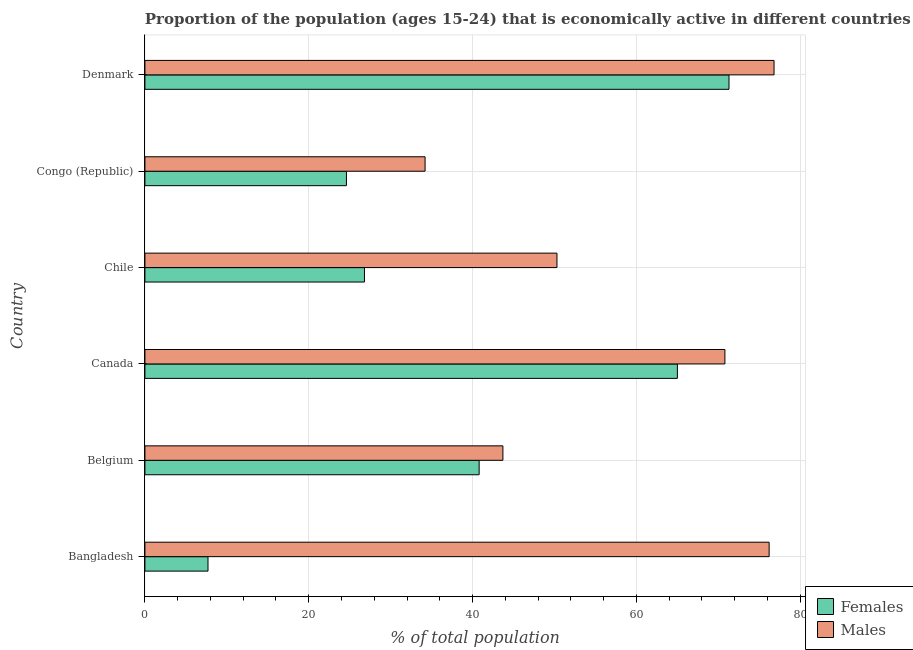How many different coloured bars are there?
Offer a very short reply. 2. How many groups of bars are there?
Ensure brevity in your answer.  6. Are the number of bars per tick equal to the number of legend labels?
Make the answer very short. Yes. How many bars are there on the 5th tick from the top?
Give a very brief answer. 2. How many bars are there on the 2nd tick from the bottom?
Provide a succinct answer. 2. What is the label of the 3rd group of bars from the top?
Make the answer very short. Chile. What is the percentage of economically active female population in Denmark?
Offer a terse response. 71.3. Across all countries, what is the maximum percentage of economically active female population?
Ensure brevity in your answer.  71.3. Across all countries, what is the minimum percentage of economically active male population?
Keep it short and to the point. 34.2. In which country was the percentage of economically active male population maximum?
Keep it short and to the point. Denmark. In which country was the percentage of economically active female population minimum?
Ensure brevity in your answer.  Bangladesh. What is the total percentage of economically active female population in the graph?
Ensure brevity in your answer.  236.2. What is the difference between the percentage of economically active male population in Chile and that in Denmark?
Offer a very short reply. -26.5. What is the difference between the percentage of economically active female population in Canada and the percentage of economically active male population in Belgium?
Provide a succinct answer. 21.3. What is the average percentage of economically active male population per country?
Offer a terse response. 58.67. What is the difference between the percentage of economically active male population and percentage of economically active female population in Canada?
Make the answer very short. 5.8. In how many countries, is the percentage of economically active female population greater than 36 %?
Your response must be concise. 3. What is the ratio of the percentage of economically active male population in Belgium to that in Canada?
Provide a short and direct response. 0.62. Is the difference between the percentage of economically active male population in Canada and Chile greater than the difference between the percentage of economically active female population in Canada and Chile?
Provide a short and direct response. No. What is the difference between the highest and the lowest percentage of economically active female population?
Your answer should be compact. 63.6. Is the sum of the percentage of economically active male population in Chile and Denmark greater than the maximum percentage of economically active female population across all countries?
Give a very brief answer. Yes. What does the 1st bar from the top in Bangladesh represents?
Make the answer very short. Males. What does the 1st bar from the bottom in Canada represents?
Provide a succinct answer. Females. Are all the bars in the graph horizontal?
Provide a short and direct response. Yes. Are the values on the major ticks of X-axis written in scientific E-notation?
Offer a very short reply. No. Does the graph contain grids?
Provide a short and direct response. Yes. What is the title of the graph?
Your answer should be compact. Proportion of the population (ages 15-24) that is economically active in different countries. Does "Private consumption" appear as one of the legend labels in the graph?
Offer a terse response. No. What is the label or title of the X-axis?
Ensure brevity in your answer.  % of total population. What is the % of total population of Females in Bangladesh?
Provide a short and direct response. 7.7. What is the % of total population in Males in Bangladesh?
Your answer should be compact. 76.2. What is the % of total population in Females in Belgium?
Your answer should be very brief. 40.8. What is the % of total population in Males in Belgium?
Your answer should be very brief. 43.7. What is the % of total population of Males in Canada?
Your response must be concise. 70.8. What is the % of total population of Females in Chile?
Keep it short and to the point. 26.8. What is the % of total population of Males in Chile?
Offer a very short reply. 50.3. What is the % of total population of Females in Congo (Republic)?
Your answer should be compact. 24.6. What is the % of total population of Males in Congo (Republic)?
Your response must be concise. 34.2. What is the % of total population of Females in Denmark?
Your answer should be very brief. 71.3. What is the % of total population of Males in Denmark?
Your answer should be compact. 76.8. Across all countries, what is the maximum % of total population of Females?
Give a very brief answer. 71.3. Across all countries, what is the maximum % of total population in Males?
Keep it short and to the point. 76.8. Across all countries, what is the minimum % of total population in Females?
Make the answer very short. 7.7. Across all countries, what is the minimum % of total population of Males?
Ensure brevity in your answer.  34.2. What is the total % of total population in Females in the graph?
Provide a short and direct response. 236.2. What is the total % of total population of Males in the graph?
Ensure brevity in your answer.  352. What is the difference between the % of total population of Females in Bangladesh and that in Belgium?
Ensure brevity in your answer.  -33.1. What is the difference between the % of total population in Males in Bangladesh and that in Belgium?
Provide a short and direct response. 32.5. What is the difference between the % of total population in Females in Bangladesh and that in Canada?
Provide a short and direct response. -57.3. What is the difference between the % of total population of Males in Bangladesh and that in Canada?
Offer a terse response. 5.4. What is the difference between the % of total population of Females in Bangladesh and that in Chile?
Provide a succinct answer. -19.1. What is the difference between the % of total population in Males in Bangladesh and that in Chile?
Your answer should be very brief. 25.9. What is the difference between the % of total population in Females in Bangladesh and that in Congo (Republic)?
Your answer should be compact. -16.9. What is the difference between the % of total population of Males in Bangladesh and that in Congo (Republic)?
Ensure brevity in your answer.  42. What is the difference between the % of total population of Females in Bangladesh and that in Denmark?
Offer a very short reply. -63.6. What is the difference between the % of total population in Females in Belgium and that in Canada?
Ensure brevity in your answer.  -24.2. What is the difference between the % of total population in Males in Belgium and that in Canada?
Keep it short and to the point. -27.1. What is the difference between the % of total population of Females in Belgium and that in Chile?
Give a very brief answer. 14. What is the difference between the % of total population in Females in Belgium and that in Congo (Republic)?
Keep it short and to the point. 16.2. What is the difference between the % of total population of Males in Belgium and that in Congo (Republic)?
Your answer should be very brief. 9.5. What is the difference between the % of total population of Females in Belgium and that in Denmark?
Offer a very short reply. -30.5. What is the difference between the % of total population of Males in Belgium and that in Denmark?
Provide a succinct answer. -33.1. What is the difference between the % of total population in Females in Canada and that in Chile?
Keep it short and to the point. 38.2. What is the difference between the % of total population of Females in Canada and that in Congo (Republic)?
Keep it short and to the point. 40.4. What is the difference between the % of total population of Males in Canada and that in Congo (Republic)?
Your answer should be very brief. 36.6. What is the difference between the % of total population in Males in Canada and that in Denmark?
Your answer should be compact. -6. What is the difference between the % of total population of Females in Chile and that in Congo (Republic)?
Offer a terse response. 2.2. What is the difference between the % of total population of Females in Chile and that in Denmark?
Make the answer very short. -44.5. What is the difference between the % of total population of Males in Chile and that in Denmark?
Your answer should be very brief. -26.5. What is the difference between the % of total population in Females in Congo (Republic) and that in Denmark?
Your response must be concise. -46.7. What is the difference between the % of total population in Males in Congo (Republic) and that in Denmark?
Your answer should be compact. -42.6. What is the difference between the % of total population in Females in Bangladesh and the % of total population in Males in Belgium?
Give a very brief answer. -36. What is the difference between the % of total population of Females in Bangladesh and the % of total population of Males in Canada?
Make the answer very short. -63.1. What is the difference between the % of total population in Females in Bangladesh and the % of total population in Males in Chile?
Provide a short and direct response. -42.6. What is the difference between the % of total population in Females in Bangladesh and the % of total population in Males in Congo (Republic)?
Ensure brevity in your answer.  -26.5. What is the difference between the % of total population of Females in Bangladesh and the % of total population of Males in Denmark?
Provide a short and direct response. -69.1. What is the difference between the % of total population of Females in Belgium and the % of total population of Males in Canada?
Provide a short and direct response. -30. What is the difference between the % of total population in Females in Belgium and the % of total population in Males in Denmark?
Provide a succinct answer. -36. What is the difference between the % of total population of Females in Canada and the % of total population of Males in Chile?
Keep it short and to the point. 14.7. What is the difference between the % of total population in Females in Canada and the % of total population in Males in Congo (Republic)?
Provide a short and direct response. 30.8. What is the difference between the % of total population in Females in Canada and the % of total population in Males in Denmark?
Provide a short and direct response. -11.8. What is the difference between the % of total population of Females in Chile and the % of total population of Males in Congo (Republic)?
Your response must be concise. -7.4. What is the difference between the % of total population of Females in Congo (Republic) and the % of total population of Males in Denmark?
Make the answer very short. -52.2. What is the average % of total population of Females per country?
Give a very brief answer. 39.37. What is the average % of total population of Males per country?
Offer a very short reply. 58.67. What is the difference between the % of total population of Females and % of total population of Males in Bangladesh?
Your answer should be compact. -68.5. What is the difference between the % of total population in Females and % of total population in Males in Canada?
Your response must be concise. -5.8. What is the difference between the % of total population of Females and % of total population of Males in Chile?
Provide a short and direct response. -23.5. What is the difference between the % of total population of Females and % of total population of Males in Congo (Republic)?
Make the answer very short. -9.6. What is the ratio of the % of total population of Females in Bangladesh to that in Belgium?
Make the answer very short. 0.19. What is the ratio of the % of total population of Males in Bangladesh to that in Belgium?
Give a very brief answer. 1.74. What is the ratio of the % of total population in Females in Bangladesh to that in Canada?
Your response must be concise. 0.12. What is the ratio of the % of total population in Males in Bangladesh to that in Canada?
Your answer should be compact. 1.08. What is the ratio of the % of total population in Females in Bangladesh to that in Chile?
Offer a very short reply. 0.29. What is the ratio of the % of total population of Males in Bangladesh to that in Chile?
Offer a very short reply. 1.51. What is the ratio of the % of total population in Females in Bangladesh to that in Congo (Republic)?
Provide a short and direct response. 0.31. What is the ratio of the % of total population in Males in Bangladesh to that in Congo (Republic)?
Provide a short and direct response. 2.23. What is the ratio of the % of total population of Females in Bangladesh to that in Denmark?
Give a very brief answer. 0.11. What is the ratio of the % of total population of Females in Belgium to that in Canada?
Your answer should be very brief. 0.63. What is the ratio of the % of total population of Males in Belgium to that in Canada?
Your response must be concise. 0.62. What is the ratio of the % of total population in Females in Belgium to that in Chile?
Offer a terse response. 1.52. What is the ratio of the % of total population in Males in Belgium to that in Chile?
Your response must be concise. 0.87. What is the ratio of the % of total population of Females in Belgium to that in Congo (Republic)?
Your answer should be compact. 1.66. What is the ratio of the % of total population of Males in Belgium to that in Congo (Republic)?
Provide a short and direct response. 1.28. What is the ratio of the % of total population in Females in Belgium to that in Denmark?
Offer a very short reply. 0.57. What is the ratio of the % of total population in Males in Belgium to that in Denmark?
Give a very brief answer. 0.57. What is the ratio of the % of total population of Females in Canada to that in Chile?
Provide a succinct answer. 2.43. What is the ratio of the % of total population of Males in Canada to that in Chile?
Your answer should be very brief. 1.41. What is the ratio of the % of total population of Females in Canada to that in Congo (Republic)?
Provide a short and direct response. 2.64. What is the ratio of the % of total population of Males in Canada to that in Congo (Republic)?
Offer a terse response. 2.07. What is the ratio of the % of total population in Females in Canada to that in Denmark?
Offer a terse response. 0.91. What is the ratio of the % of total population of Males in Canada to that in Denmark?
Offer a terse response. 0.92. What is the ratio of the % of total population in Females in Chile to that in Congo (Republic)?
Provide a short and direct response. 1.09. What is the ratio of the % of total population in Males in Chile to that in Congo (Republic)?
Provide a short and direct response. 1.47. What is the ratio of the % of total population in Females in Chile to that in Denmark?
Make the answer very short. 0.38. What is the ratio of the % of total population in Males in Chile to that in Denmark?
Give a very brief answer. 0.65. What is the ratio of the % of total population of Females in Congo (Republic) to that in Denmark?
Make the answer very short. 0.34. What is the ratio of the % of total population in Males in Congo (Republic) to that in Denmark?
Provide a short and direct response. 0.45. What is the difference between the highest and the lowest % of total population in Females?
Your answer should be compact. 63.6. What is the difference between the highest and the lowest % of total population of Males?
Ensure brevity in your answer.  42.6. 